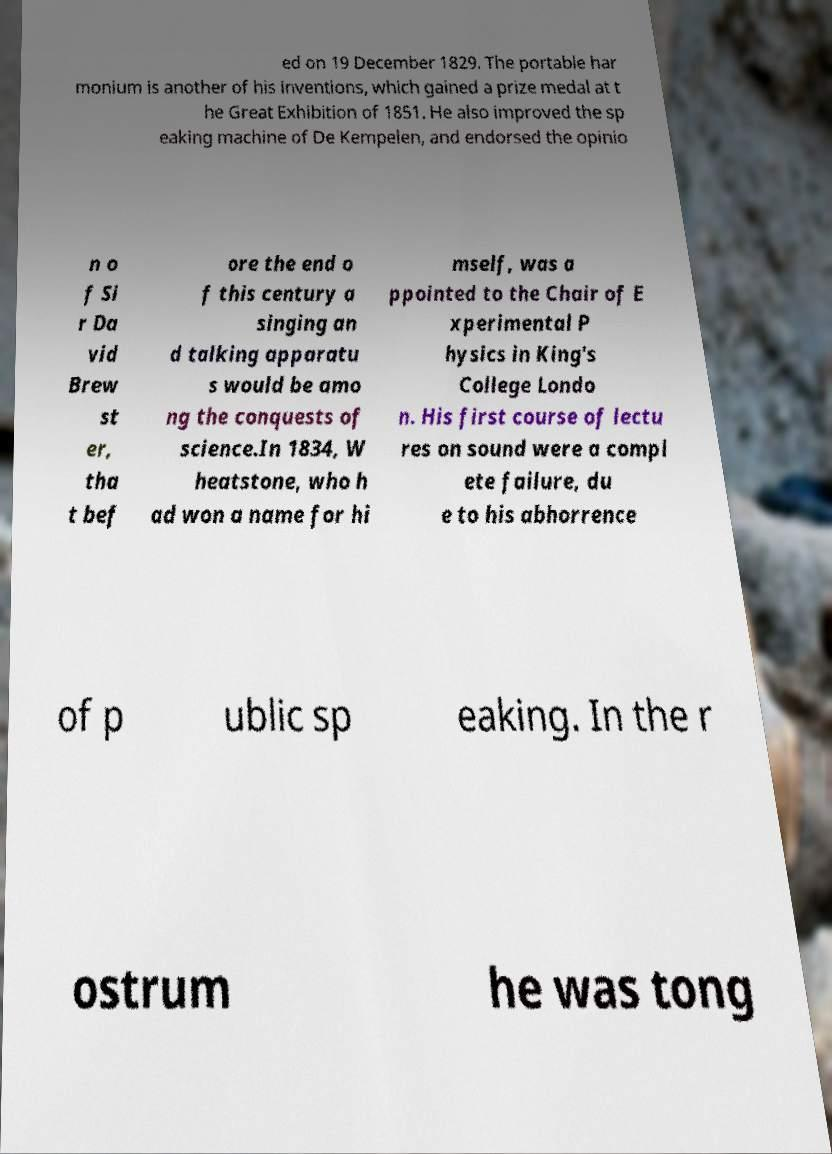What messages or text are displayed in this image? I need them in a readable, typed format. ed on 19 December 1829. The portable har monium is another of his inventions, which gained a prize medal at t he Great Exhibition of 1851. He also improved the sp eaking machine of De Kempelen, and endorsed the opinio n o f Si r Da vid Brew st er, tha t bef ore the end o f this century a singing an d talking apparatu s would be amo ng the conquests of science.In 1834, W heatstone, who h ad won a name for hi mself, was a ppointed to the Chair of E xperimental P hysics in King's College Londo n. His first course of lectu res on sound were a compl ete failure, du e to his abhorrence of p ublic sp eaking. In the r ostrum he was tong 